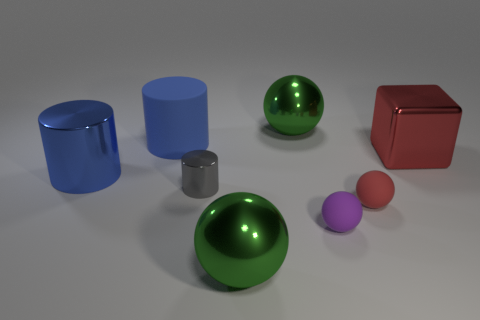Are there any tiny purple objects of the same shape as the blue rubber thing? no 